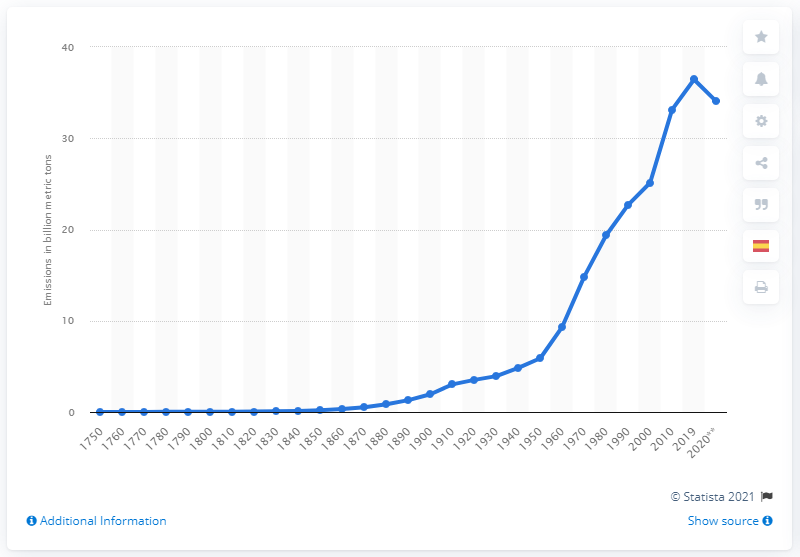Indicate a few pertinent items in this graphic. In 2019, a total of 36.44 metric tons of carbon dioxide was emitted. 